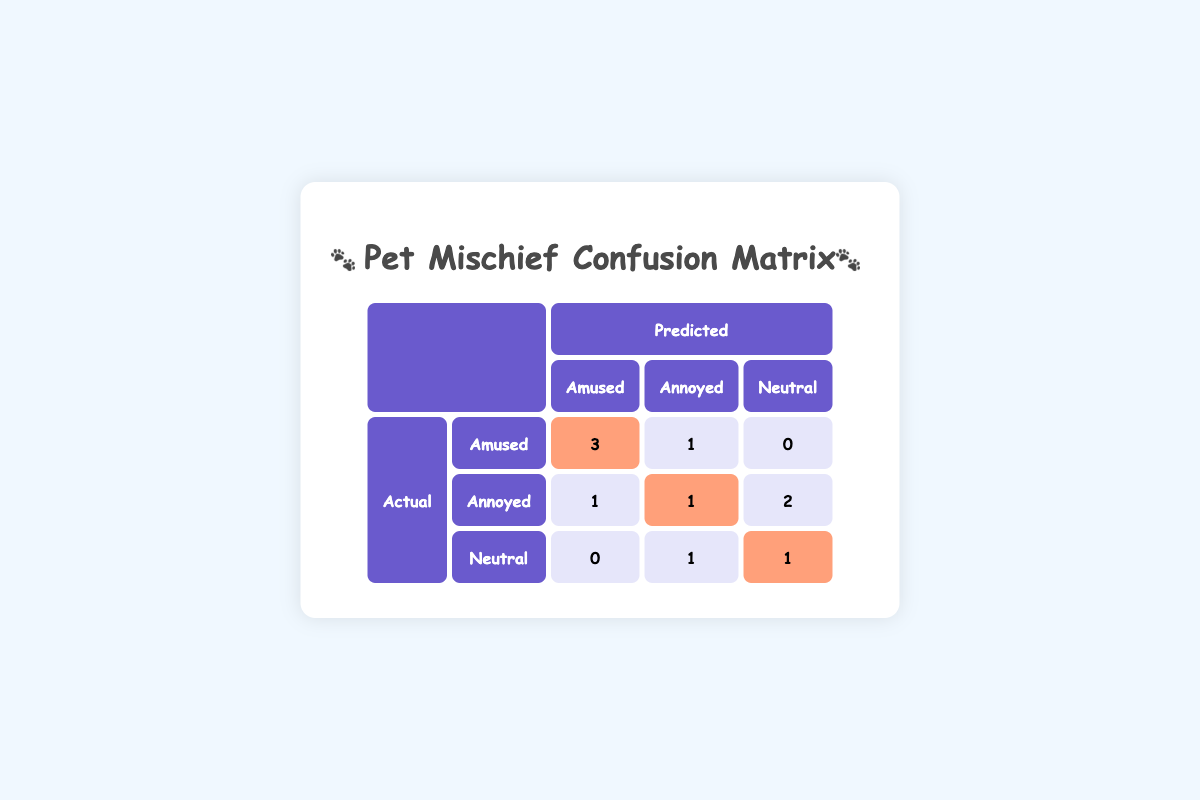What is the number of instances where the actual response was amused, and the predicted response was also amused? From the table, we can see that in the "Amused" row under the "Amused" column, the value is 3. This indicates that there were 3 instances where the actual response of the owner was "amused," and they were also predicted to be "amused."
Answer: 3 How many times were the owners annoyed when they were predicted to be amused? Looking at the "Annoyed" row under the "Amused" column, we find a value of 1. This means there was 1 instance where the owner actually felt "annoyed," but the prediction indicated they were "amused."
Answer: 1 What is the total number of instances when owners were predicted to be neutral? To find this, we can sum the values in the "Neutral" column: 0 (Amused) + 1 (Annoyed) + 1 (Neutral) = 2. Thus, there were 2 total instances where the owners were predicted to be neutral.
Answer: 2 Are there more instances of owners being predicted as annoyed than neutral? The values in the "Annoyed" column show 1 (Amused) + 2 (Annoyed) + 1 (Neutral) = 4. In the "Neutral" column, the values add up to 0 (Amused) + 1 (Annoyed) + 1 (Neutral) = 2. Since 4 > 2, it is true that there are more predicted annoyed instances.
Answer: Yes What is the total number of correct predictions made? Correct predictions occur when the actual response matches the predicted response. From the table, the diagonal values are 3 (Amused) + 2 (Annoyed) + 1 (Neutral) = 6. Therefore, the total number of correct predictions is 6.
Answer: 6 How many instances did owners experience mischief but were predicted to be neutral? Looking at the "Neutral" row, we see the values 0 (Amused) + 1 (Annoyed) + 1 (Neutral) = 2. Therefore, owners experienced mischief in 2 instances while being predicted as neutral.
Answer: 2 What percentage of cases were the owners actually amused according to the actual responses? The total number of responses is 10. The actual "amused" count is 4 (3 + 1 from the first row). So, the percentage is (4/10) * 100 = 40%.
Answer: 40% How does the number of owners who were actually neutral compare to those who were predicted as annoyed? From the table, owners actually neutral = 1 and those predicted annoyed = 4. Since 1 < 4, the number of actual neutrals is less than the predicted annoyed.
Answer: No 